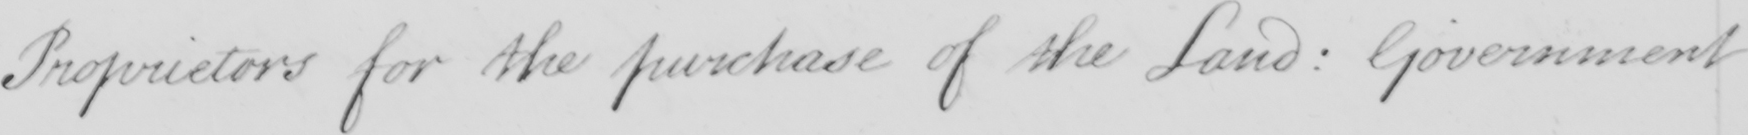What is written in this line of handwriting? Proprietors for the purchase of the Land: Government 